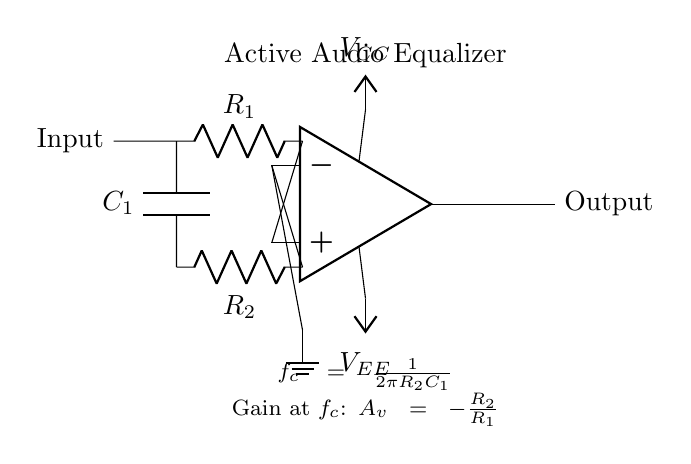What is the configuration of this filter circuit? The circuit is an active filter, utilizing operational amplifiers to achieve precise audio equalization. It employs a feedback network with resistors and a capacitor to set its frequency response.
Answer: Active filter What components are used in the feedback network? The feedback network consists of a resistor labeled R2 and a capacitor labeled C1. These components work together to determine the filter's characteristics.
Answer: R2 and C1 What is the function of the capacitor in this circuit? The capacitor C1 in this filter circuit allows for frequency-dependent behavior, affecting how different frequencies are amplified or attenuated. It helps shape the frequency response of the equalizer.
Answer: Frequency response shaping How is the cutoff frequency calculated in this circuit? The cutoff frequency is calculated using the formula f_c = 1 / (2πR2C1), where R2 is the feedback resistor and C1 is the capacitor. This formula derives from the principles of reactive components in filter design.
Answer: 1 / (2πR2C1) What is the gain at the cutoff frequency? The gain at the cutoff frequency is given by the expression A_v = -R2 / R1, where R1 is the resistor at the input. This negative gain indicates the phase inversion alongside the amplification factor.
Answer: -R2 / R1 What type of filter is represented in this circuit? The circuit represents a low-pass filter, allowing signals at frequencies below the cutoff frequency to pass through while attenuating higher frequencies.
Answer: Low-pass filter What are the power supply voltages in this circuit? The power supply voltages marked are V_CC and V_EE. V_CC is the positive supply voltage, and V_EE is the negative supply voltage, essential for the operation of the op-amp.
Answer: V_CC and V_EE 